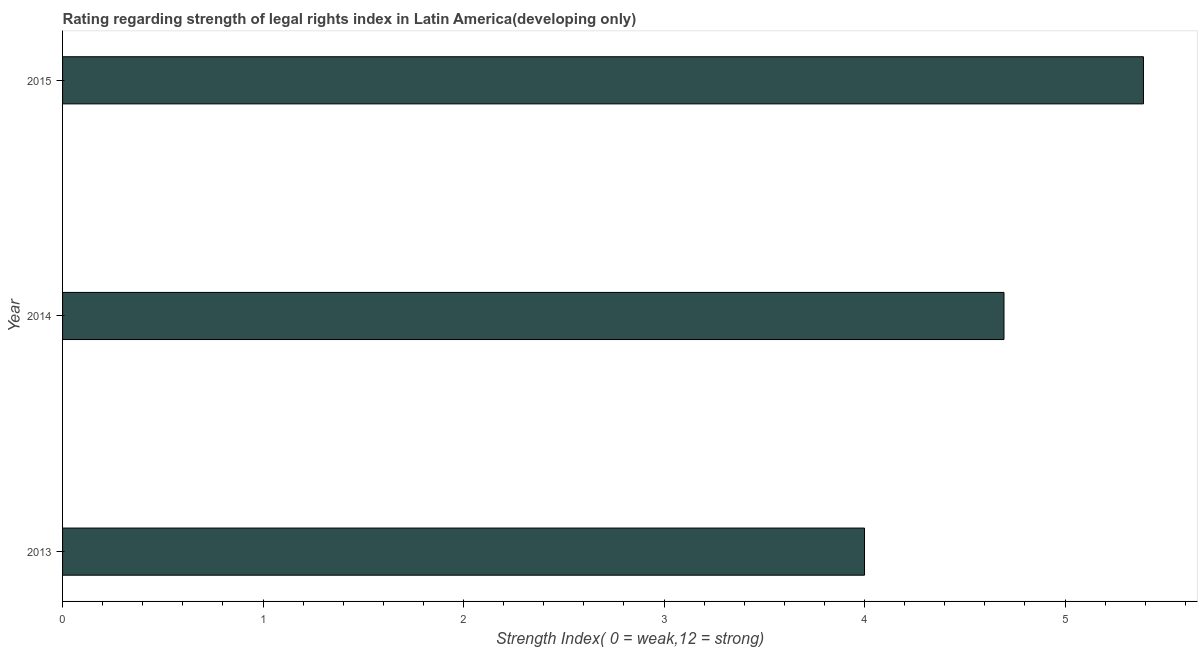What is the title of the graph?
Your answer should be compact. Rating regarding strength of legal rights index in Latin America(developing only). What is the label or title of the X-axis?
Ensure brevity in your answer.  Strength Index( 0 = weak,12 = strong). What is the label or title of the Y-axis?
Provide a short and direct response. Year. What is the strength of legal rights index in 2015?
Offer a terse response. 5.39. Across all years, what is the maximum strength of legal rights index?
Provide a succinct answer. 5.39. Across all years, what is the minimum strength of legal rights index?
Ensure brevity in your answer.  4. In which year was the strength of legal rights index maximum?
Offer a very short reply. 2015. In which year was the strength of legal rights index minimum?
Keep it short and to the point. 2013. What is the sum of the strength of legal rights index?
Provide a succinct answer. 14.09. What is the difference between the strength of legal rights index in 2014 and 2015?
Give a very brief answer. -0.7. What is the average strength of legal rights index per year?
Provide a short and direct response. 4.7. What is the median strength of legal rights index?
Offer a very short reply. 4.7. What is the ratio of the strength of legal rights index in 2013 to that in 2015?
Ensure brevity in your answer.  0.74. What is the difference between the highest and the second highest strength of legal rights index?
Offer a terse response. 0.7. Is the sum of the strength of legal rights index in 2013 and 2015 greater than the maximum strength of legal rights index across all years?
Your response must be concise. Yes. What is the difference between the highest and the lowest strength of legal rights index?
Give a very brief answer. 1.39. How many bars are there?
Offer a terse response. 3. Are all the bars in the graph horizontal?
Make the answer very short. Yes. How many years are there in the graph?
Provide a short and direct response. 3. What is the Strength Index( 0 = weak,12 = strong) of 2014?
Your answer should be compact. 4.7. What is the Strength Index( 0 = weak,12 = strong) in 2015?
Ensure brevity in your answer.  5.39. What is the difference between the Strength Index( 0 = weak,12 = strong) in 2013 and 2014?
Give a very brief answer. -0.7. What is the difference between the Strength Index( 0 = weak,12 = strong) in 2013 and 2015?
Offer a terse response. -1.39. What is the difference between the Strength Index( 0 = weak,12 = strong) in 2014 and 2015?
Your response must be concise. -0.7. What is the ratio of the Strength Index( 0 = weak,12 = strong) in 2013 to that in 2014?
Provide a succinct answer. 0.85. What is the ratio of the Strength Index( 0 = weak,12 = strong) in 2013 to that in 2015?
Ensure brevity in your answer.  0.74. What is the ratio of the Strength Index( 0 = weak,12 = strong) in 2014 to that in 2015?
Give a very brief answer. 0.87. 